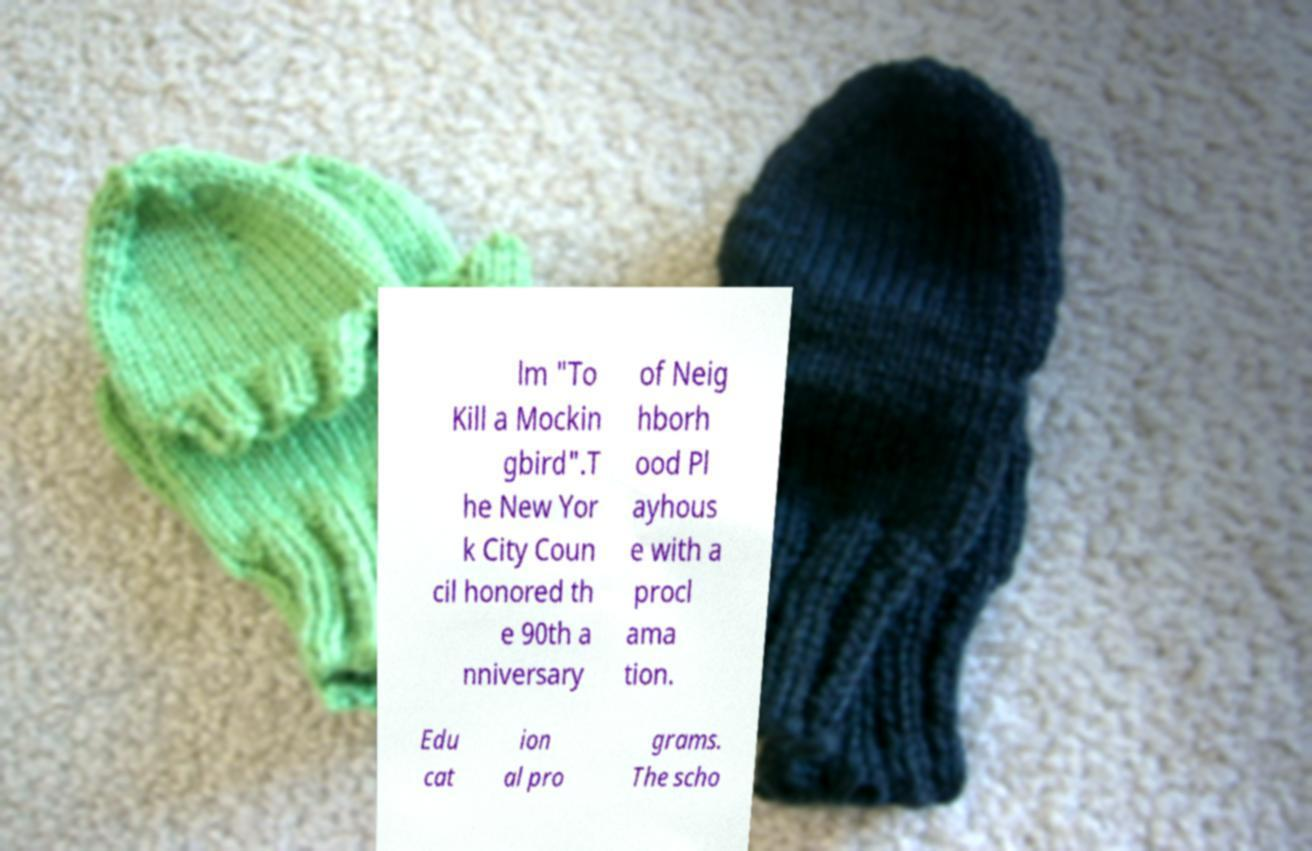Can you accurately transcribe the text from the provided image for me? lm "To Kill a Mockin gbird".T he New Yor k City Coun cil honored th e 90th a nniversary of Neig hborh ood Pl ayhous e with a procl ama tion. Edu cat ion al pro grams. The scho 